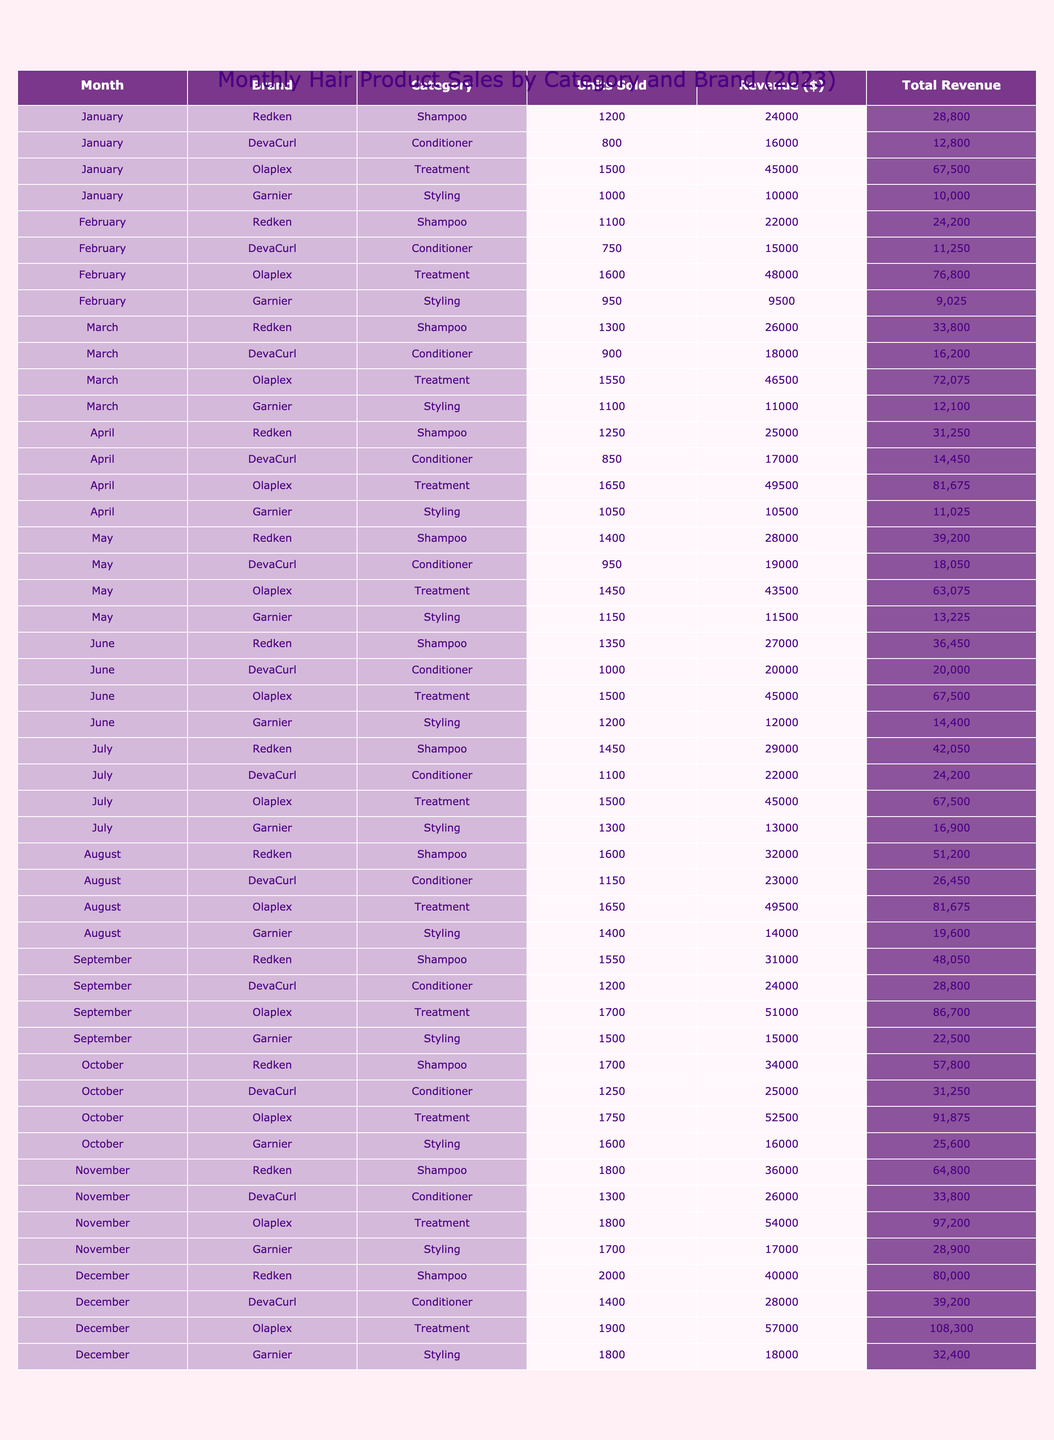What was the total revenue generated by Redken in March? In March, Redken had 1,300 units sold with a revenue of $26,000. Thus, the total revenue generated by Redken in March was $26,000.
Answer: $26,000 Which brand had the highest units sold in December? In December, Redken sold 2,000 units, which is more than any other brand in that month. The next highest was DevaCurl with 1,400 units. Therefore, Redken had the highest units sold in December.
Answer: Yes What is the average revenue generated by Olaplex for the year? To find the average revenue for Olaplex, sum its monthly revenues: $45,000 + $48,000 + $46,500 + $49,500 + $43,500 + $45,000 + $49,500 + $51,000 + $52,500 + $54,000 + $57,000 = $585,000. There are 12 months, so the average revenue is $585,000 / 12 = $48,750.
Answer: $48,750 In which month did Garnier achieve its lowest units sold? At a glance, in February, Garnier sold 950 units, which is the lowest compared to other months. The next lowest month was April with 1,050 units. Hence, February was the month with the lowest units sold for Garnier.
Answer: February How much more revenue did Olaplex generate in September compared to January? Olaplex generated $51,000 in September and $45,000 in January. The difference in revenue is $51,000 - $45,000 = $6,000.
Answer: $6,000 Was there a month where DevaCurl’s sales surpassed $20,000? Reviewing the revenue for DevaCurl: in May it was $19,000, but in June it was $20,000 and in August it reached $23,000. Therefore, there were months where DevaCurl's sales surpassed $20,000.
Answer: Yes What is the total number of units sold by all brands in July? The units sold in July are: Redken 1,450 + DevaCurl 1,100 + Olaplex 1,500 + Garnier 1,300 = 5,350. Hence, the total number of units sold in July is 5,350.
Answer: 5,350 Which brand's revenue consistently increased every month from January to December? Reviewing the revenue for Redken across the months: $24,000 (Jan), $22,000 (Feb), $26,000 (Mar), $25,000 (Apr), $28,000 (May), $27,000 (Jun), $29,000 (Jul), $32,000 (Aug), $31,000 (Sep), $34,000 (Oct), $36,000 (Nov), and $40,000 (Dec). Redken's revenue did not consistently increase, so no brand achieved this.
Answer: No What was the combined revenue of all brands in October? The revenues in October are: Redken $34,000 + DevaCurl $25,000 + Olaplex $52,500 + Garnier $16,000 = $127,500. Thus, the combined revenue in October is $127,500.
Answer: $127,500 Which month saw the highest total units sold across all brands? Adding the units for December: Redken 2,000 + DevaCurl 1,400 + Olaplex 1,900 + Garnier 1,800 = 7,100. Other months were lower than this total. Therefore, December had the highest total units sold.
Answer: December 